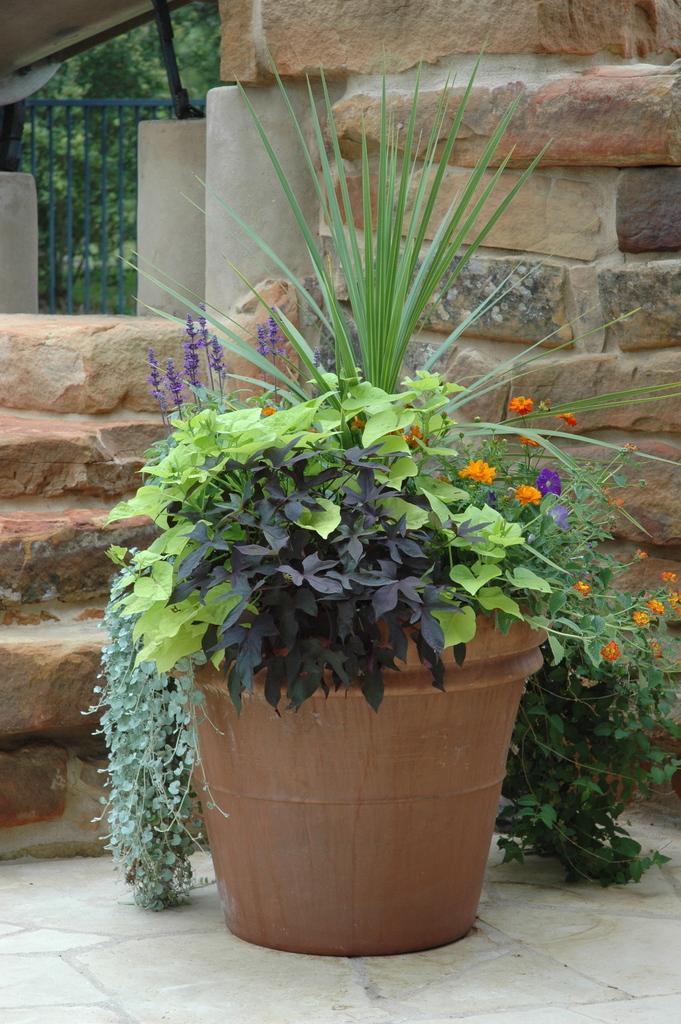Can you describe this image briefly? This image is taken outdoors. At the bottom of the image there is a floor. In the middle of the image there is a pot with a few plants in it. In the background there is a wall and there is a grill. 